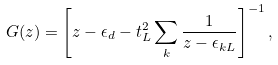Convert formula to latex. <formula><loc_0><loc_0><loc_500><loc_500>G ( z ) = \left [ z - \epsilon _ { d } - t _ { L } ^ { 2 } \sum _ { k } \frac { 1 } { z - \epsilon _ { k L } } \right ] ^ { - 1 } ,</formula> 